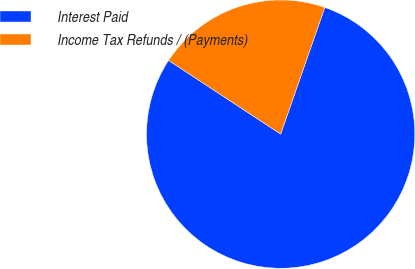Convert chart. <chart><loc_0><loc_0><loc_500><loc_500><pie_chart><fcel>Interest Paid<fcel>Income Tax Refunds / (Payments)<nl><fcel>78.92%<fcel>21.08%<nl></chart> 